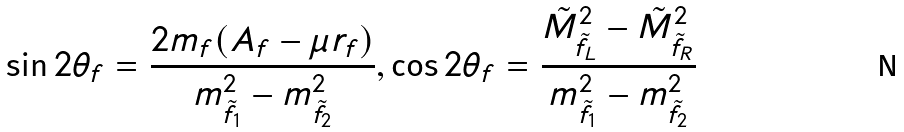<formula> <loc_0><loc_0><loc_500><loc_500>\sin 2 \theta _ { f } = \frac { 2 m _ { f } ( A _ { f } - \mu r _ { f } ) } { m _ { \tilde { f } _ { 1 } } ^ { 2 } - m _ { \tilde { f } _ { 2 } } ^ { 2 } } , \cos 2 \theta _ { f } = \frac { \tilde { M } _ { \tilde { f } _ { L } } ^ { 2 } - \tilde { M } _ { \tilde { f } _ { R } } ^ { 2 } } { m _ { \tilde { f } _ { 1 } } ^ { 2 } - m _ { \tilde { f } _ { 2 } } ^ { 2 } }</formula> 